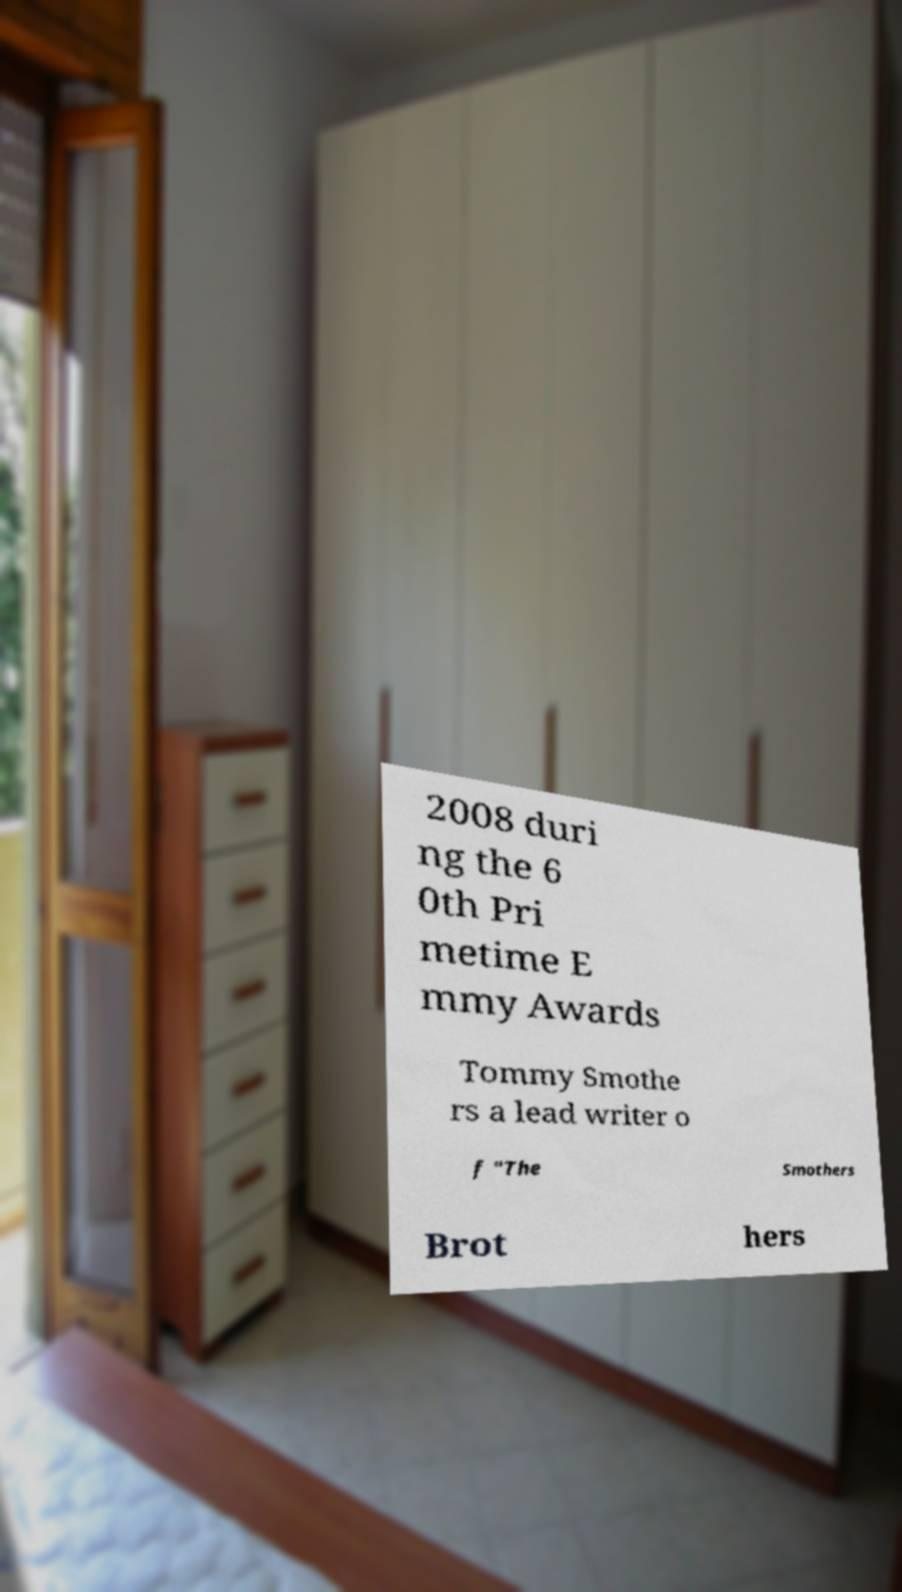There's text embedded in this image that I need extracted. Can you transcribe it verbatim? 2008 duri ng the 6 0th Pri metime E mmy Awards Tommy Smothe rs a lead writer o f "The Smothers Brot hers 